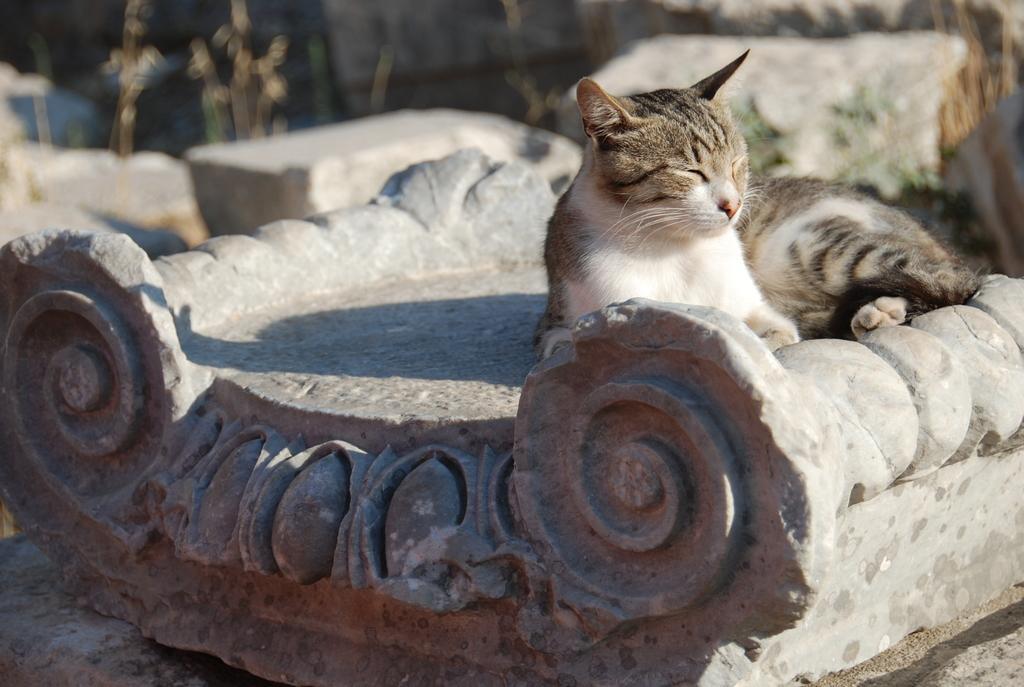Can you describe this image briefly? In this image we can see a cat and also the concrete structures. The background is blurred. 